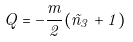Convert formula to latex. <formula><loc_0><loc_0><loc_500><loc_500>Q = - \frac { m } { 2 } ( \tilde { n } _ { 3 } + 1 )</formula> 